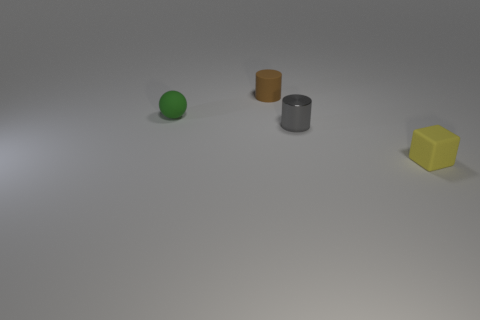Are the gray cylinder and the tiny object to the left of the tiny brown cylinder made of the same material?
Your answer should be very brief. No. What is the tiny cylinder that is behind the small gray metal cylinder in front of the small green ball made of?
Give a very brief answer. Rubber. Is the number of tiny yellow matte cubes to the left of the gray cylinder greater than the number of tiny green matte spheres?
Offer a terse response. No. Is there a green metal thing?
Make the answer very short. No. There is a matte thing behind the green matte object; what is its color?
Give a very brief answer. Brown. There is a green object that is the same size as the cube; what is its material?
Give a very brief answer. Rubber. How many other objects are there of the same material as the tiny brown object?
Your response must be concise. 2. What is the color of the tiny matte thing that is both in front of the brown object and to the left of the tiny block?
Ensure brevity in your answer.  Green. How many things are things that are in front of the small brown matte object or small matte cylinders?
Provide a short and direct response. 4. How many other objects are there of the same color as the small metallic thing?
Give a very brief answer. 0. 